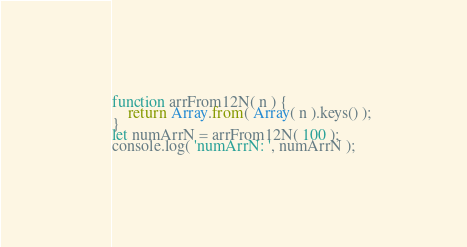<code> <loc_0><loc_0><loc_500><loc_500><_JavaScript_>function arrFrom12N( n ) {
    return Array.from( Array( n ).keys() );
}
let numArrN = arrFrom12N( 100 );
console.log( 'numArrN: ', numArrN );</code> 